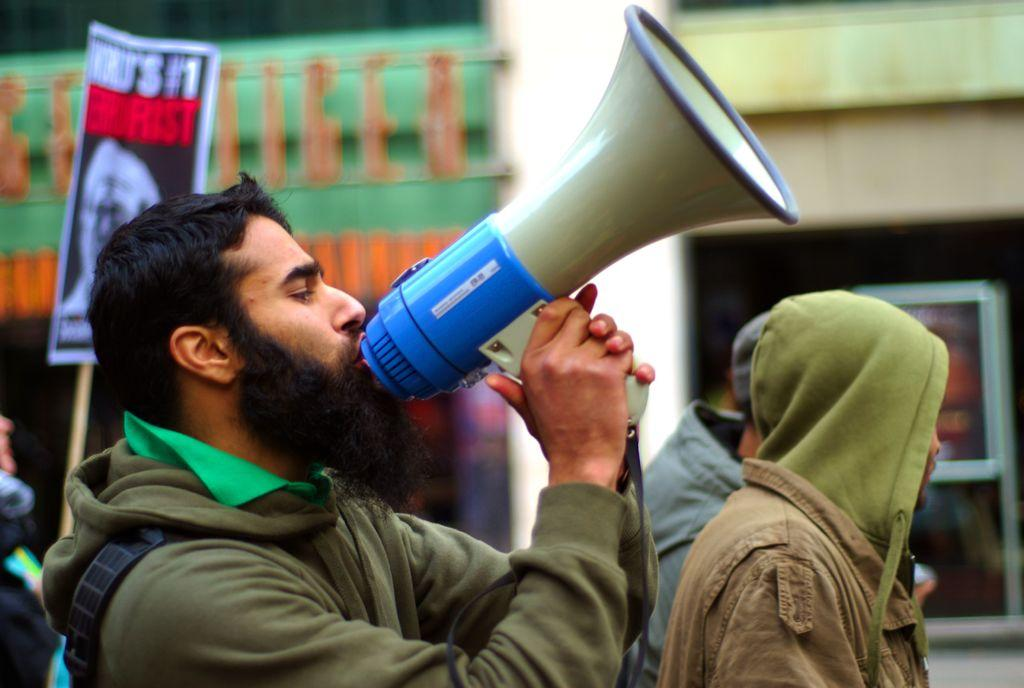What is the person in the foreground of the image holding? The person in the foreground of the image is holding a megaphone. Can you describe the people visible on the backside of the image? There are people visible on the backside of the image, but their specific actions or features are not clear from the provided facts. What is the person on the right side of the image holding? One person is holding a board with a stick in the image. What is the temperature of the toes visible in the image? There are no toes visible in the image, so it is not possible to determine their temperature. 